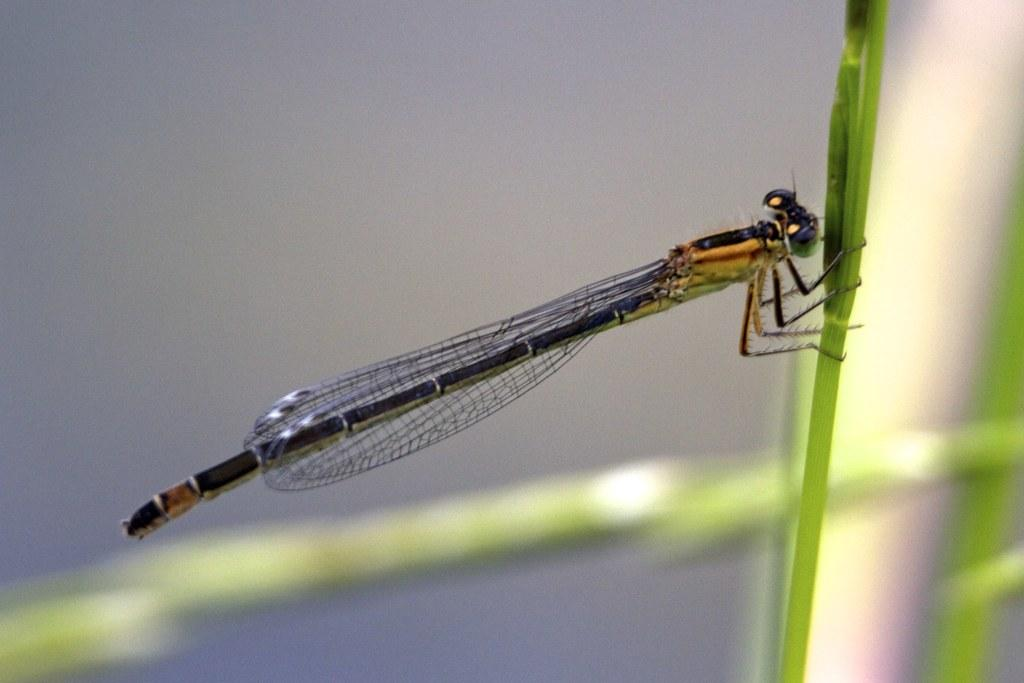What is the main subject of the image? The main subject of the image is a dragonfly. What is the dragonfly holding in the image? The dragonfly is holding a leaf in the image. Can you describe the background of the image? The background of the image is blurred. What statement does the dragonfly make in the image? Dragonflies do not make statements, as they are insects and do not have the ability to communicate through language. Can you tell me when the dragonfly was born in the image? There is no information about the dragonfly's birth in the image. --- 